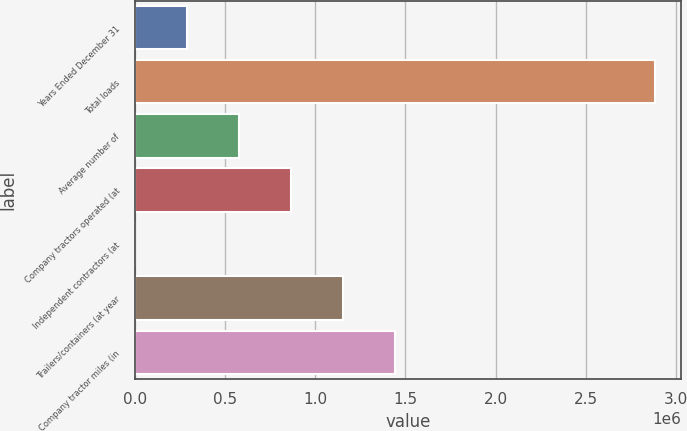Convert chart. <chart><loc_0><loc_0><loc_500><loc_500><bar_chart><fcel>Years Ended December 31<fcel>Total loads<fcel>Average number of<fcel>Company tractors operated (at<fcel>Independent contractors (at<fcel>Trailers/containers (at year<fcel>Company tractor miles (in<nl><fcel>289521<fcel>2.8835e+06<fcel>577742<fcel>865962<fcel>1301<fcel>1.15418e+06<fcel>1.4424e+06<nl></chart> 